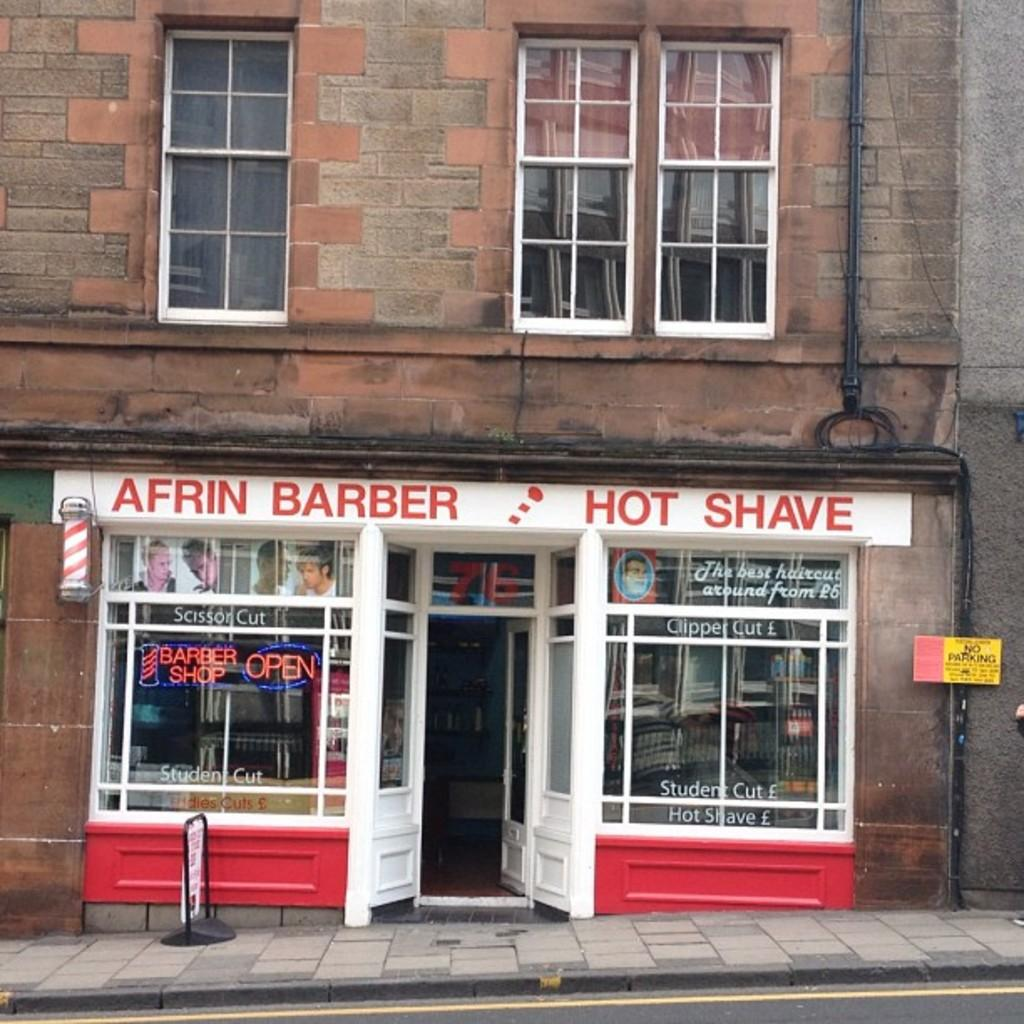What type of establishment is in the center of the image? There is a barber shop in the center of the image. Can you describe the windows in the image? There are windows at the top side of the image. What type of nut can be seen on the street outside the barber shop in the image? There is no nut visible on the street outside the barber shop in the image. 